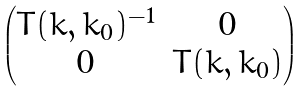<formula> <loc_0><loc_0><loc_500><loc_500>\begin{pmatrix} T ( k , k _ { 0 } ) ^ { - 1 } & 0 \\ 0 & T ( k , k _ { 0 } ) \end{pmatrix}</formula> 